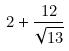Convert formula to latex. <formula><loc_0><loc_0><loc_500><loc_500>2 + \frac { 1 2 } { \sqrt { 1 3 } }</formula> 